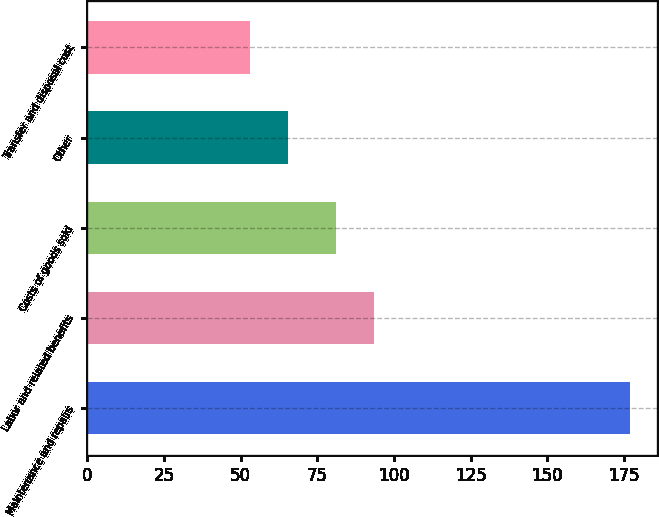<chart> <loc_0><loc_0><loc_500><loc_500><bar_chart><fcel>Maintenance and repairs<fcel>Labor and related benefits<fcel>Costs of goods sold<fcel>Other<fcel>Transfer and disposal cost<nl><fcel>177<fcel>93.4<fcel>81<fcel>65.4<fcel>53<nl></chart> 